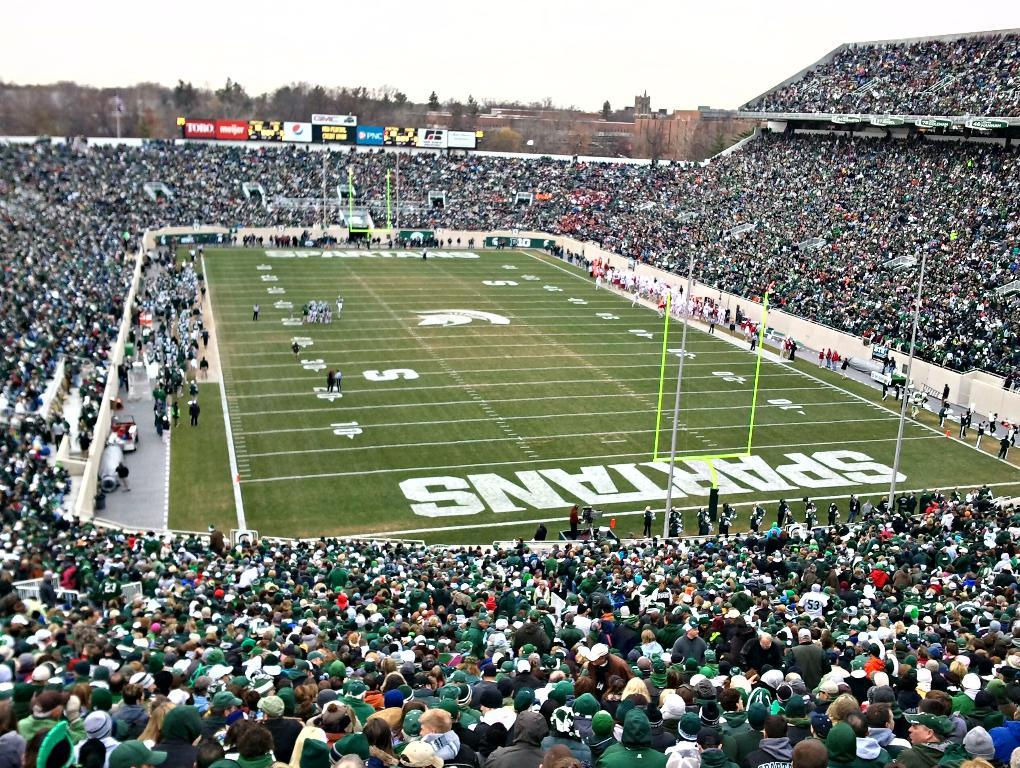<image>
Present a compact description of the photo's key features. A football field with Spartans written in the end zone. 